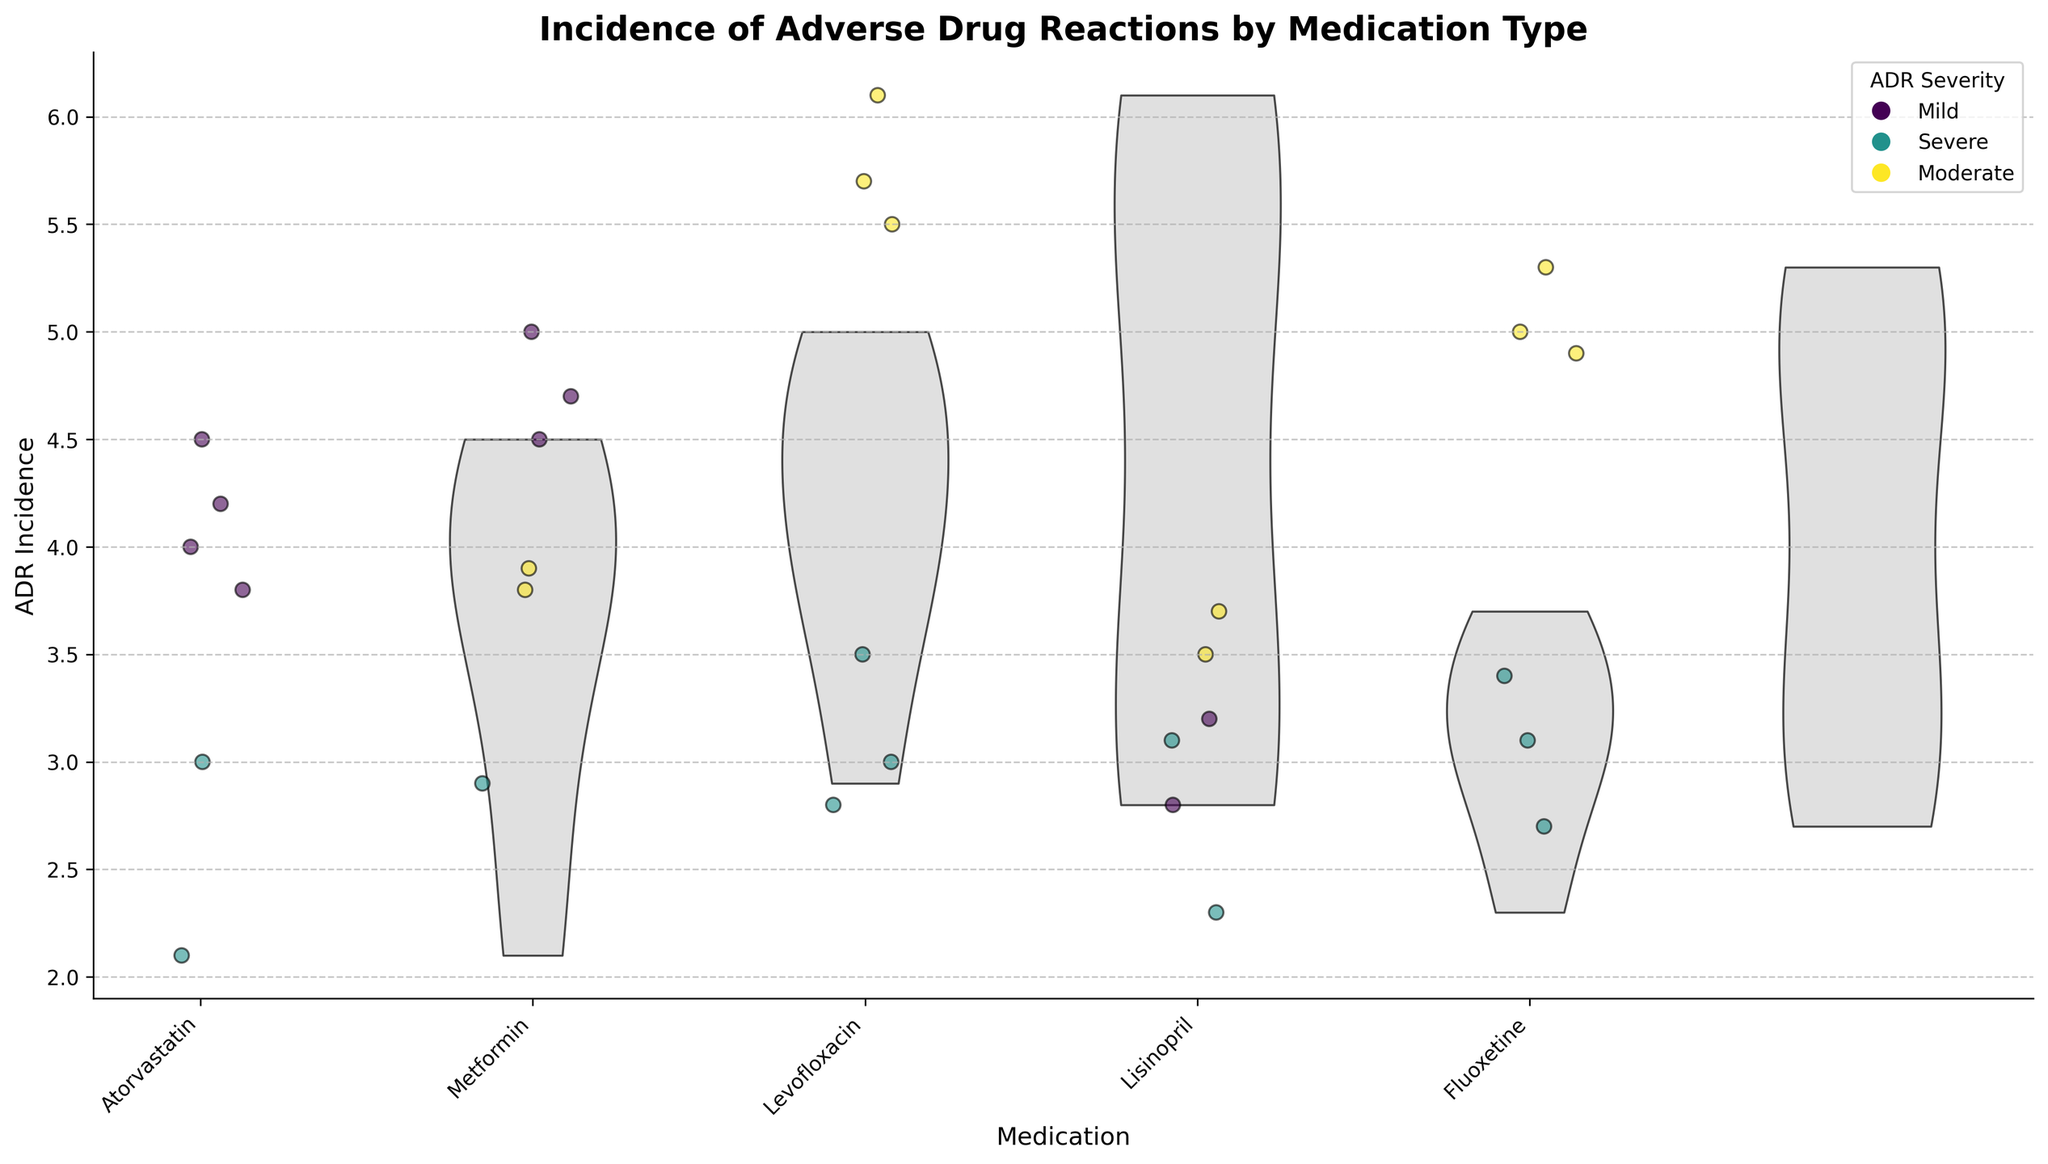Which medication shows the highest average incidence of adverse drug reactions? By examining the vertical spread and concentration of points within each violin plot, we observe that Levofloxacin has the highest incidence values concentrated around 6.1 to 5.5.
Answer: Levofloxacin What is the title of the figure? The title is displayed at the top of the figure in a larger, bold font.
Answer: Incidence of Adverse Drug Reactions by Medication Type How is the severity of adverse drug reactions indicated in the plot? The colors of the jittered points represent different severities of ADRs, which are explained in the legend on the upper right.
Answer: By color of the points Which age demographic shows the highest incidence of severe ADRs for Atorvastatin? Points for severe ADRs are red; for Atorvastatin, the highest incidence (around 3.0) is observed in the Age_66+ demographic.
Answer: Age_66+ Which medication has the lowest average ADR incidence? Lisinopril’s violin plot has the lowest vertical spread and concentration of points around the lower incidence values.
Answer: Lisinopril For which medication do ADR incidences vary the most across different demographics? The violin plots' width is a good indicator of variance. For Levofloxacin, the plot spreads widely, indicating high variance.
Answer: Levofloxacin Among which demographics does Lisinopril show severe ADRs? By referring to the points colored for severe ADRs on Lisinopril’s plot, severe incidences appear in Age_56-65 and Age_66+.
Answer: Age_56-65 and Age_66+ Is there a general trend in ADR incidence severity with age for any medication? By comparing incidences across age groups within each medication’s plot, a general trend shows that severe ADRs tend to increase in incidence as the age increases.
Answer: Severity increases with age What are the axis titles for the x and y axes? The bottom of the plot labels the medications on the x-axis, and the y-axis title appears on the left side indicating ADR Incidence.
Answer: Medication and ADR Incidence Which demographic group has the highest incidence of mild ADRs for Metformin? Mild ADRs for Metformin are shown in the highest points around 5.0, occurring in the Age_18-25 demographic.
Answer: Age_18-25 